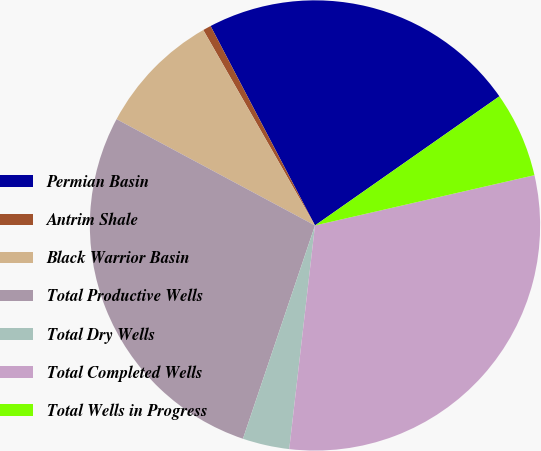<chart> <loc_0><loc_0><loc_500><loc_500><pie_chart><fcel>Permian Basin<fcel>Antrim Shale<fcel>Black Warrior Basin<fcel>Total Productive Wells<fcel>Total Dry Wells<fcel>Total Completed Wells<fcel>Total Wells in Progress<nl><fcel>22.95%<fcel>0.59%<fcel>8.91%<fcel>27.64%<fcel>3.36%<fcel>30.41%<fcel>6.14%<nl></chart> 